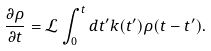<formula> <loc_0><loc_0><loc_500><loc_500>\frac { \partial \rho } { \partial t } = \mathcal { L } \int _ { 0 } ^ { t } d t ^ { \prime } k ( t ^ { \prime } ) \rho ( t - t ^ { \prime } ) .</formula> 